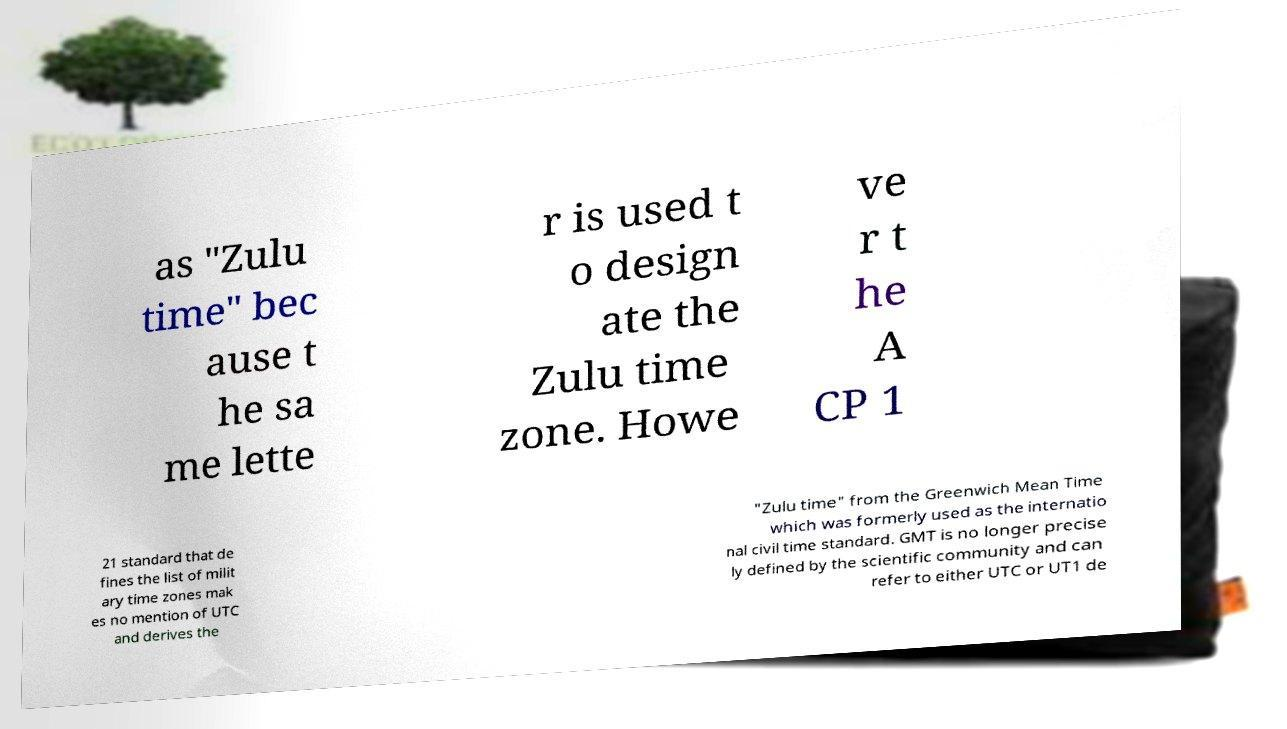Can you read and provide the text displayed in the image?This photo seems to have some interesting text. Can you extract and type it out for me? as "Zulu time" bec ause t he sa me lette r is used t o design ate the Zulu time zone. Howe ve r t he A CP 1 21 standard that de fines the list of milit ary time zones mak es no mention of UTC and derives the "Zulu time" from the Greenwich Mean Time which was formerly used as the internatio nal civil time standard. GMT is no longer precise ly defined by the scientific community and can refer to either UTC or UT1 de 